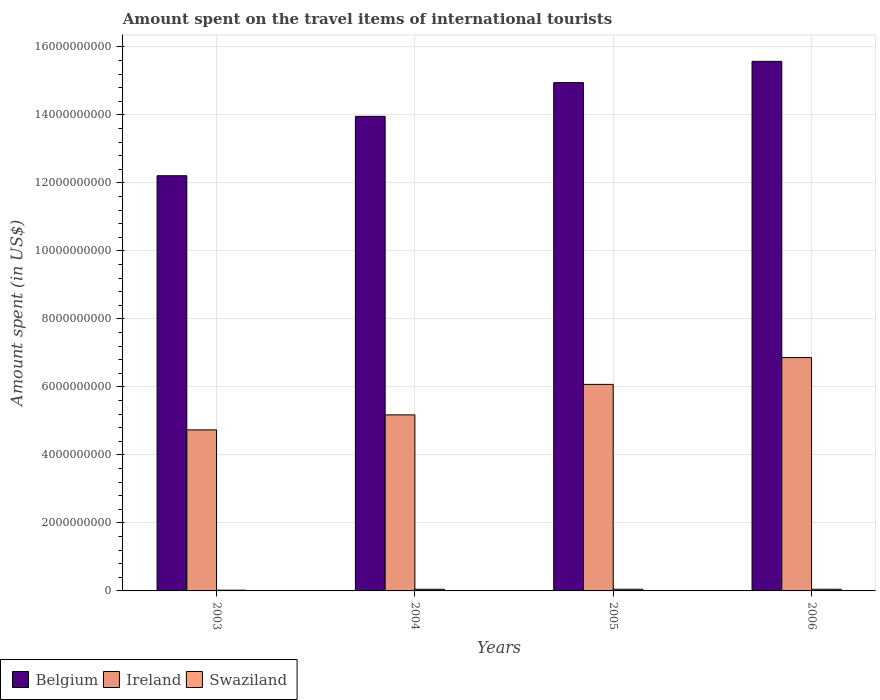Are the number of bars per tick equal to the number of legend labels?
Provide a succinct answer. Yes. Are the number of bars on each tick of the X-axis equal?
Give a very brief answer. Yes. What is the label of the 2nd group of bars from the left?
Provide a succinct answer. 2004. In how many cases, is the number of bars for a given year not equal to the number of legend labels?
Provide a short and direct response. 0. What is the amount spent on the travel items of international tourists in Ireland in 2003?
Keep it short and to the point. 4.74e+09. Across all years, what is the maximum amount spent on the travel items of international tourists in Ireland?
Your answer should be very brief. 6.86e+09. Across all years, what is the minimum amount spent on the travel items of international tourists in Ireland?
Provide a short and direct response. 4.74e+09. What is the total amount spent on the travel items of international tourists in Belgium in the graph?
Your response must be concise. 5.67e+1. What is the difference between the amount spent on the travel items of international tourists in Belgium in 2004 and that in 2006?
Your response must be concise. -1.62e+09. What is the difference between the amount spent on the travel items of international tourists in Belgium in 2005 and the amount spent on the travel items of international tourists in Ireland in 2004?
Your answer should be compact. 9.77e+09. What is the average amount spent on the travel items of international tourists in Ireland per year?
Give a very brief answer. 5.71e+09. In the year 2005, what is the difference between the amount spent on the travel items of international tourists in Ireland and amount spent on the travel items of international tourists in Belgium?
Ensure brevity in your answer.  -8.87e+09. What is the ratio of the amount spent on the travel items of international tourists in Belgium in 2003 to that in 2006?
Keep it short and to the point. 0.78. Is the amount spent on the travel items of international tourists in Belgium in 2004 less than that in 2006?
Make the answer very short. Yes. Is the difference between the amount spent on the travel items of international tourists in Ireland in 2005 and 2006 greater than the difference between the amount spent on the travel items of international tourists in Belgium in 2005 and 2006?
Give a very brief answer. No. What is the difference between the highest and the second highest amount spent on the travel items of international tourists in Belgium?
Provide a short and direct response. 6.26e+08. What is the difference between the highest and the lowest amount spent on the travel items of international tourists in Ireland?
Your answer should be very brief. 2.13e+09. What does the 2nd bar from the right in 2006 represents?
Make the answer very short. Ireland. What is the difference between two consecutive major ticks on the Y-axis?
Ensure brevity in your answer.  2.00e+09. Are the values on the major ticks of Y-axis written in scientific E-notation?
Keep it short and to the point. No. Does the graph contain any zero values?
Offer a very short reply. No. How many legend labels are there?
Provide a succinct answer. 3. How are the legend labels stacked?
Your answer should be very brief. Horizontal. What is the title of the graph?
Your answer should be very brief. Amount spent on the travel items of international tourists. Does "Chad" appear as one of the legend labels in the graph?
Offer a terse response. No. What is the label or title of the Y-axis?
Your answer should be very brief. Amount spent (in US$). What is the Amount spent (in US$) in Belgium in 2003?
Offer a very short reply. 1.22e+1. What is the Amount spent (in US$) in Ireland in 2003?
Your answer should be very brief. 4.74e+09. What is the Amount spent (in US$) in Swaziland in 2003?
Offer a very short reply. 2.20e+07. What is the Amount spent (in US$) of Belgium in 2004?
Your answer should be compact. 1.40e+1. What is the Amount spent (in US$) of Ireland in 2004?
Offer a very short reply. 5.18e+09. What is the Amount spent (in US$) in Swaziland in 2004?
Your answer should be compact. 4.80e+07. What is the Amount spent (in US$) in Belgium in 2005?
Keep it short and to the point. 1.49e+1. What is the Amount spent (in US$) of Ireland in 2005?
Offer a very short reply. 6.07e+09. What is the Amount spent (in US$) in Swaziland in 2005?
Your answer should be compact. 4.90e+07. What is the Amount spent (in US$) of Belgium in 2006?
Your answer should be compact. 1.56e+1. What is the Amount spent (in US$) in Ireland in 2006?
Provide a succinct answer. 6.86e+09. What is the Amount spent (in US$) in Swaziland in 2006?
Offer a very short reply. 4.90e+07. Across all years, what is the maximum Amount spent (in US$) in Belgium?
Ensure brevity in your answer.  1.56e+1. Across all years, what is the maximum Amount spent (in US$) of Ireland?
Offer a terse response. 6.86e+09. Across all years, what is the maximum Amount spent (in US$) in Swaziland?
Offer a very short reply. 4.90e+07. Across all years, what is the minimum Amount spent (in US$) in Belgium?
Keep it short and to the point. 1.22e+1. Across all years, what is the minimum Amount spent (in US$) in Ireland?
Your answer should be very brief. 4.74e+09. Across all years, what is the minimum Amount spent (in US$) of Swaziland?
Keep it short and to the point. 2.20e+07. What is the total Amount spent (in US$) in Belgium in the graph?
Your answer should be compact. 5.67e+1. What is the total Amount spent (in US$) in Ireland in the graph?
Offer a very short reply. 2.28e+1. What is the total Amount spent (in US$) in Swaziland in the graph?
Offer a very short reply. 1.68e+08. What is the difference between the Amount spent (in US$) of Belgium in 2003 and that in 2004?
Ensure brevity in your answer.  -1.75e+09. What is the difference between the Amount spent (in US$) of Ireland in 2003 and that in 2004?
Keep it short and to the point. -4.41e+08. What is the difference between the Amount spent (in US$) in Swaziland in 2003 and that in 2004?
Offer a very short reply. -2.60e+07. What is the difference between the Amount spent (in US$) of Belgium in 2003 and that in 2005?
Give a very brief answer. -2.74e+09. What is the difference between the Amount spent (in US$) of Ireland in 2003 and that in 2005?
Offer a terse response. -1.34e+09. What is the difference between the Amount spent (in US$) in Swaziland in 2003 and that in 2005?
Provide a succinct answer. -2.70e+07. What is the difference between the Amount spent (in US$) of Belgium in 2003 and that in 2006?
Your answer should be compact. -3.36e+09. What is the difference between the Amount spent (in US$) of Ireland in 2003 and that in 2006?
Keep it short and to the point. -2.13e+09. What is the difference between the Amount spent (in US$) in Swaziland in 2003 and that in 2006?
Keep it short and to the point. -2.70e+07. What is the difference between the Amount spent (in US$) in Belgium in 2004 and that in 2005?
Provide a short and direct response. -9.92e+08. What is the difference between the Amount spent (in US$) of Ireland in 2004 and that in 2005?
Your answer should be very brief. -8.97e+08. What is the difference between the Amount spent (in US$) of Swaziland in 2004 and that in 2005?
Your answer should be very brief. -1.00e+06. What is the difference between the Amount spent (in US$) in Belgium in 2004 and that in 2006?
Your response must be concise. -1.62e+09. What is the difference between the Amount spent (in US$) of Ireland in 2004 and that in 2006?
Make the answer very short. -1.68e+09. What is the difference between the Amount spent (in US$) of Swaziland in 2004 and that in 2006?
Your answer should be compact. -1.00e+06. What is the difference between the Amount spent (in US$) in Belgium in 2005 and that in 2006?
Make the answer very short. -6.26e+08. What is the difference between the Amount spent (in US$) of Ireland in 2005 and that in 2006?
Offer a terse response. -7.88e+08. What is the difference between the Amount spent (in US$) of Belgium in 2003 and the Amount spent (in US$) of Ireland in 2004?
Make the answer very short. 7.03e+09. What is the difference between the Amount spent (in US$) in Belgium in 2003 and the Amount spent (in US$) in Swaziland in 2004?
Make the answer very short. 1.22e+1. What is the difference between the Amount spent (in US$) in Ireland in 2003 and the Amount spent (in US$) in Swaziland in 2004?
Offer a terse response. 4.69e+09. What is the difference between the Amount spent (in US$) in Belgium in 2003 and the Amount spent (in US$) in Ireland in 2005?
Offer a very short reply. 6.14e+09. What is the difference between the Amount spent (in US$) in Belgium in 2003 and the Amount spent (in US$) in Swaziland in 2005?
Keep it short and to the point. 1.22e+1. What is the difference between the Amount spent (in US$) of Ireland in 2003 and the Amount spent (in US$) of Swaziland in 2005?
Your answer should be very brief. 4.69e+09. What is the difference between the Amount spent (in US$) of Belgium in 2003 and the Amount spent (in US$) of Ireland in 2006?
Your answer should be very brief. 5.35e+09. What is the difference between the Amount spent (in US$) of Belgium in 2003 and the Amount spent (in US$) of Swaziland in 2006?
Your response must be concise. 1.22e+1. What is the difference between the Amount spent (in US$) of Ireland in 2003 and the Amount spent (in US$) of Swaziland in 2006?
Offer a very short reply. 4.69e+09. What is the difference between the Amount spent (in US$) in Belgium in 2004 and the Amount spent (in US$) in Ireland in 2005?
Your answer should be very brief. 7.88e+09. What is the difference between the Amount spent (in US$) in Belgium in 2004 and the Amount spent (in US$) in Swaziland in 2005?
Provide a short and direct response. 1.39e+1. What is the difference between the Amount spent (in US$) in Ireland in 2004 and the Amount spent (in US$) in Swaziland in 2005?
Your answer should be compact. 5.13e+09. What is the difference between the Amount spent (in US$) in Belgium in 2004 and the Amount spent (in US$) in Ireland in 2006?
Keep it short and to the point. 7.09e+09. What is the difference between the Amount spent (in US$) in Belgium in 2004 and the Amount spent (in US$) in Swaziland in 2006?
Ensure brevity in your answer.  1.39e+1. What is the difference between the Amount spent (in US$) of Ireland in 2004 and the Amount spent (in US$) of Swaziland in 2006?
Keep it short and to the point. 5.13e+09. What is the difference between the Amount spent (in US$) in Belgium in 2005 and the Amount spent (in US$) in Ireland in 2006?
Ensure brevity in your answer.  8.09e+09. What is the difference between the Amount spent (in US$) of Belgium in 2005 and the Amount spent (in US$) of Swaziland in 2006?
Ensure brevity in your answer.  1.49e+1. What is the difference between the Amount spent (in US$) of Ireland in 2005 and the Amount spent (in US$) of Swaziland in 2006?
Keep it short and to the point. 6.02e+09. What is the average Amount spent (in US$) in Belgium per year?
Make the answer very short. 1.42e+1. What is the average Amount spent (in US$) of Ireland per year?
Ensure brevity in your answer.  5.71e+09. What is the average Amount spent (in US$) in Swaziland per year?
Keep it short and to the point. 4.20e+07. In the year 2003, what is the difference between the Amount spent (in US$) of Belgium and Amount spent (in US$) of Ireland?
Offer a very short reply. 7.47e+09. In the year 2003, what is the difference between the Amount spent (in US$) of Belgium and Amount spent (in US$) of Swaziland?
Provide a short and direct response. 1.22e+1. In the year 2003, what is the difference between the Amount spent (in US$) of Ireland and Amount spent (in US$) of Swaziland?
Provide a succinct answer. 4.71e+09. In the year 2004, what is the difference between the Amount spent (in US$) of Belgium and Amount spent (in US$) of Ireland?
Your response must be concise. 8.78e+09. In the year 2004, what is the difference between the Amount spent (in US$) of Belgium and Amount spent (in US$) of Swaziland?
Make the answer very short. 1.39e+1. In the year 2004, what is the difference between the Amount spent (in US$) of Ireland and Amount spent (in US$) of Swaziland?
Your answer should be very brief. 5.13e+09. In the year 2005, what is the difference between the Amount spent (in US$) of Belgium and Amount spent (in US$) of Ireland?
Offer a terse response. 8.87e+09. In the year 2005, what is the difference between the Amount spent (in US$) of Belgium and Amount spent (in US$) of Swaziland?
Your answer should be very brief. 1.49e+1. In the year 2005, what is the difference between the Amount spent (in US$) of Ireland and Amount spent (in US$) of Swaziland?
Ensure brevity in your answer.  6.02e+09. In the year 2006, what is the difference between the Amount spent (in US$) of Belgium and Amount spent (in US$) of Ireland?
Keep it short and to the point. 8.71e+09. In the year 2006, what is the difference between the Amount spent (in US$) of Belgium and Amount spent (in US$) of Swaziland?
Your answer should be very brief. 1.55e+1. In the year 2006, what is the difference between the Amount spent (in US$) in Ireland and Amount spent (in US$) in Swaziland?
Provide a short and direct response. 6.81e+09. What is the ratio of the Amount spent (in US$) in Belgium in 2003 to that in 2004?
Ensure brevity in your answer.  0.87. What is the ratio of the Amount spent (in US$) of Ireland in 2003 to that in 2004?
Offer a very short reply. 0.91. What is the ratio of the Amount spent (in US$) in Swaziland in 2003 to that in 2004?
Offer a terse response. 0.46. What is the ratio of the Amount spent (in US$) in Belgium in 2003 to that in 2005?
Give a very brief answer. 0.82. What is the ratio of the Amount spent (in US$) in Ireland in 2003 to that in 2005?
Your answer should be compact. 0.78. What is the ratio of the Amount spent (in US$) of Swaziland in 2003 to that in 2005?
Your response must be concise. 0.45. What is the ratio of the Amount spent (in US$) in Belgium in 2003 to that in 2006?
Provide a succinct answer. 0.78. What is the ratio of the Amount spent (in US$) in Ireland in 2003 to that in 2006?
Provide a succinct answer. 0.69. What is the ratio of the Amount spent (in US$) in Swaziland in 2003 to that in 2006?
Ensure brevity in your answer.  0.45. What is the ratio of the Amount spent (in US$) of Belgium in 2004 to that in 2005?
Your answer should be very brief. 0.93. What is the ratio of the Amount spent (in US$) of Ireland in 2004 to that in 2005?
Keep it short and to the point. 0.85. What is the ratio of the Amount spent (in US$) of Swaziland in 2004 to that in 2005?
Make the answer very short. 0.98. What is the ratio of the Amount spent (in US$) of Belgium in 2004 to that in 2006?
Ensure brevity in your answer.  0.9. What is the ratio of the Amount spent (in US$) in Ireland in 2004 to that in 2006?
Provide a succinct answer. 0.75. What is the ratio of the Amount spent (in US$) in Swaziland in 2004 to that in 2006?
Offer a very short reply. 0.98. What is the ratio of the Amount spent (in US$) of Belgium in 2005 to that in 2006?
Provide a short and direct response. 0.96. What is the ratio of the Amount spent (in US$) in Ireland in 2005 to that in 2006?
Provide a short and direct response. 0.89. What is the ratio of the Amount spent (in US$) in Swaziland in 2005 to that in 2006?
Give a very brief answer. 1. What is the difference between the highest and the second highest Amount spent (in US$) in Belgium?
Offer a terse response. 6.26e+08. What is the difference between the highest and the second highest Amount spent (in US$) in Ireland?
Your answer should be compact. 7.88e+08. What is the difference between the highest and the second highest Amount spent (in US$) in Swaziland?
Provide a succinct answer. 0. What is the difference between the highest and the lowest Amount spent (in US$) in Belgium?
Keep it short and to the point. 3.36e+09. What is the difference between the highest and the lowest Amount spent (in US$) of Ireland?
Your answer should be compact. 2.13e+09. What is the difference between the highest and the lowest Amount spent (in US$) in Swaziland?
Ensure brevity in your answer.  2.70e+07. 